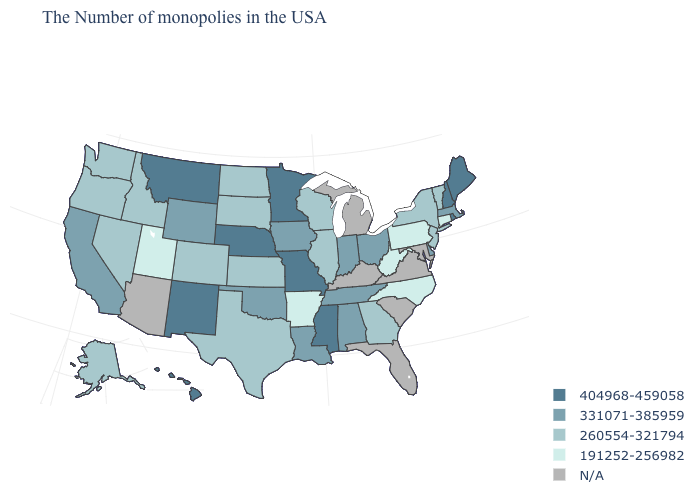Does Maine have the highest value in the Northeast?
Short answer required. Yes. Which states hav the highest value in the South?
Answer briefly. Mississippi. Among the states that border Massachusetts , does New York have the highest value?
Short answer required. No. Which states have the lowest value in the Northeast?
Short answer required. Connecticut, Pennsylvania. Which states hav the highest value in the MidWest?
Keep it brief. Missouri, Minnesota, Nebraska. Does North Carolina have the lowest value in the South?
Write a very short answer. Yes. What is the lowest value in the South?
Be succinct. 191252-256982. What is the value of Wyoming?
Write a very short answer. 331071-385959. Which states have the lowest value in the South?
Keep it brief. North Carolina, West Virginia, Arkansas. Name the states that have a value in the range 331071-385959?
Write a very short answer. Massachusetts, Delaware, Ohio, Indiana, Alabama, Tennessee, Louisiana, Iowa, Oklahoma, Wyoming, California. Does the map have missing data?
Write a very short answer. Yes. What is the value of Oregon?
Write a very short answer. 260554-321794. Is the legend a continuous bar?
Answer briefly. No. 